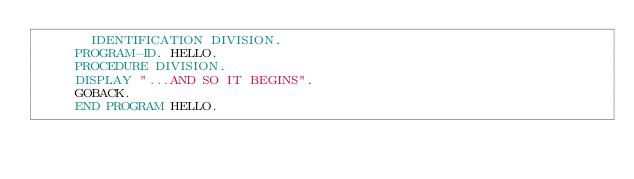Convert code to text. <code><loc_0><loc_0><loc_500><loc_500><_COBOL_>       IDENTIFICATION DIVISION.
	   PROGRAM-ID. HELLO.
	   PROCEDURE DIVISION.
	   DISPLAY "...AND SO IT BEGINS".
	   GOBACK.
	   END PROGRAM HELLO.
</code> 